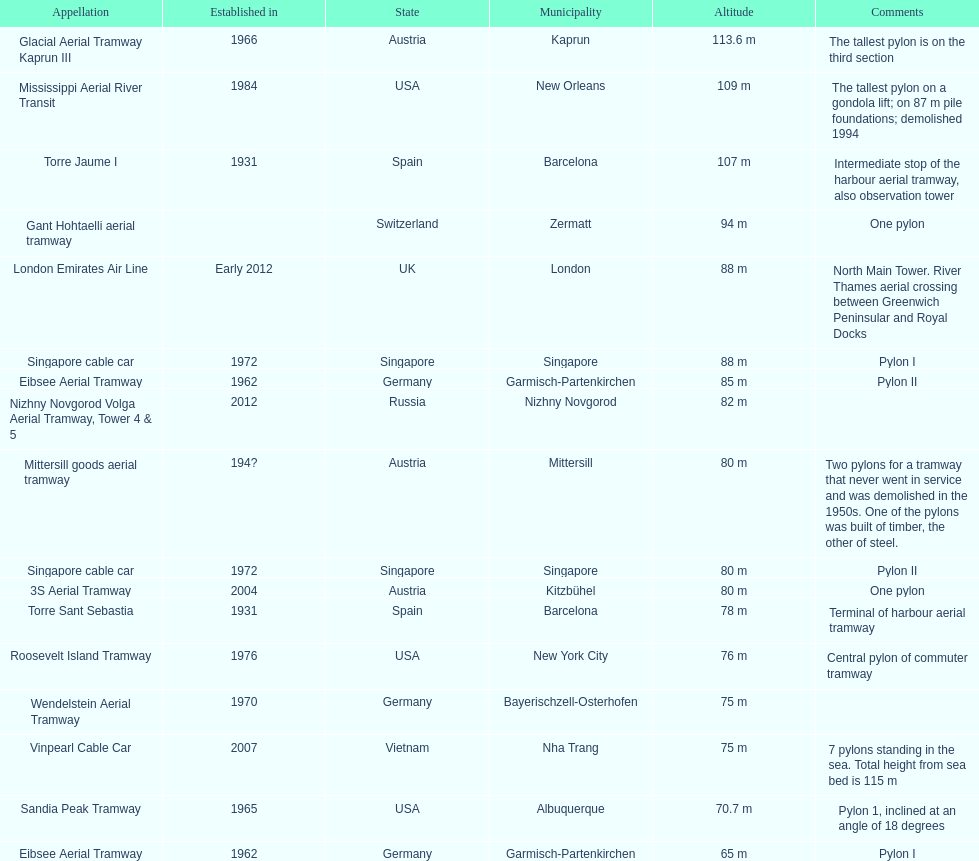How many pylons are in austria? 3. 